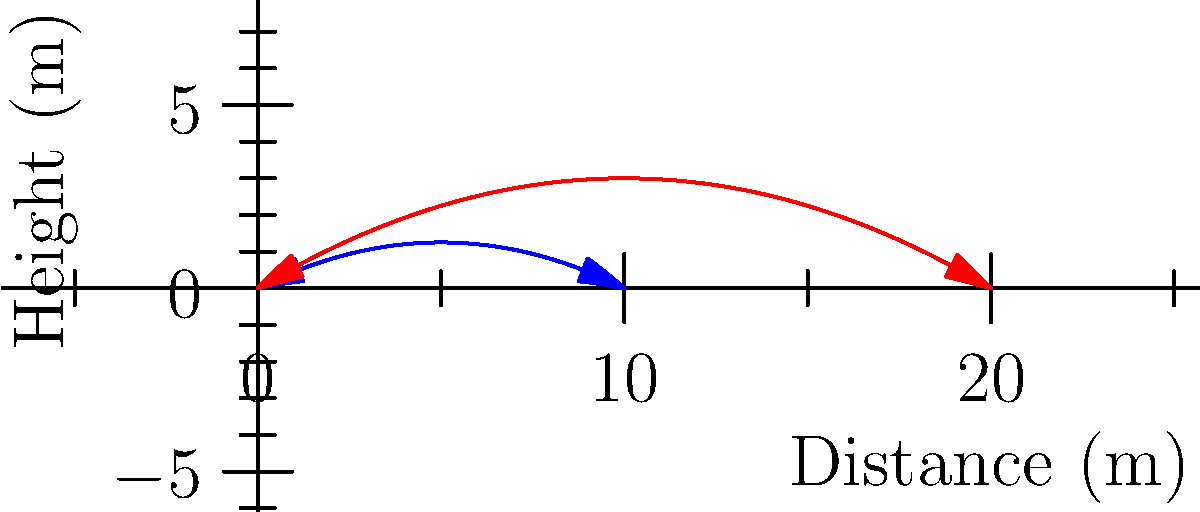A soccer ball is kicked from ground level at two different angles: 30° and 45°. The trajectories of the ball are shown in the graph, with the red curve representing the 30° kick and the blue curve representing the 45° kick. If the maximum height reached by the ball kicked at 45° is 2.5 meters, what is the approximate maximum height reached by the ball kicked at 30°? To solve this problem, we'll follow these steps:

1) The maximum height of each trajectory occurs at the vertex of its parabola.

2) For the 45° kick (blue curve):
   - The maximum height is given as 2.5 meters.
   - This occurs at the vertex of the blue parabola.

3) For the 30° kick (red curve):
   - We need to compare the heights of the two curves.
   - The red curve appears to reach about 3/4 of the height of the blue curve.

4) To calculate the approximate maximum height of the 30° kick:
   $$\text{Height}_{\text{30°}} \approx \frac{3}{4} \times \text{Height}_{\text{45°}}$$
   $$\text{Height}_{\text{30°}} \approx \frac{3}{4} \times 2.5 \text{ meters}$$
   $$\text{Height}_{\text{30°}} \approx 1.875 \text{ meters}$$

5) Rounding to a reasonable precision for this estimate:
   $$\text{Height}_{\text{30°}} \approx 1.9 \text{ meters}$$

Therefore, the ball kicked at a 30° angle reaches an approximate maximum height of 1.9 meters.
Answer: 1.9 meters 